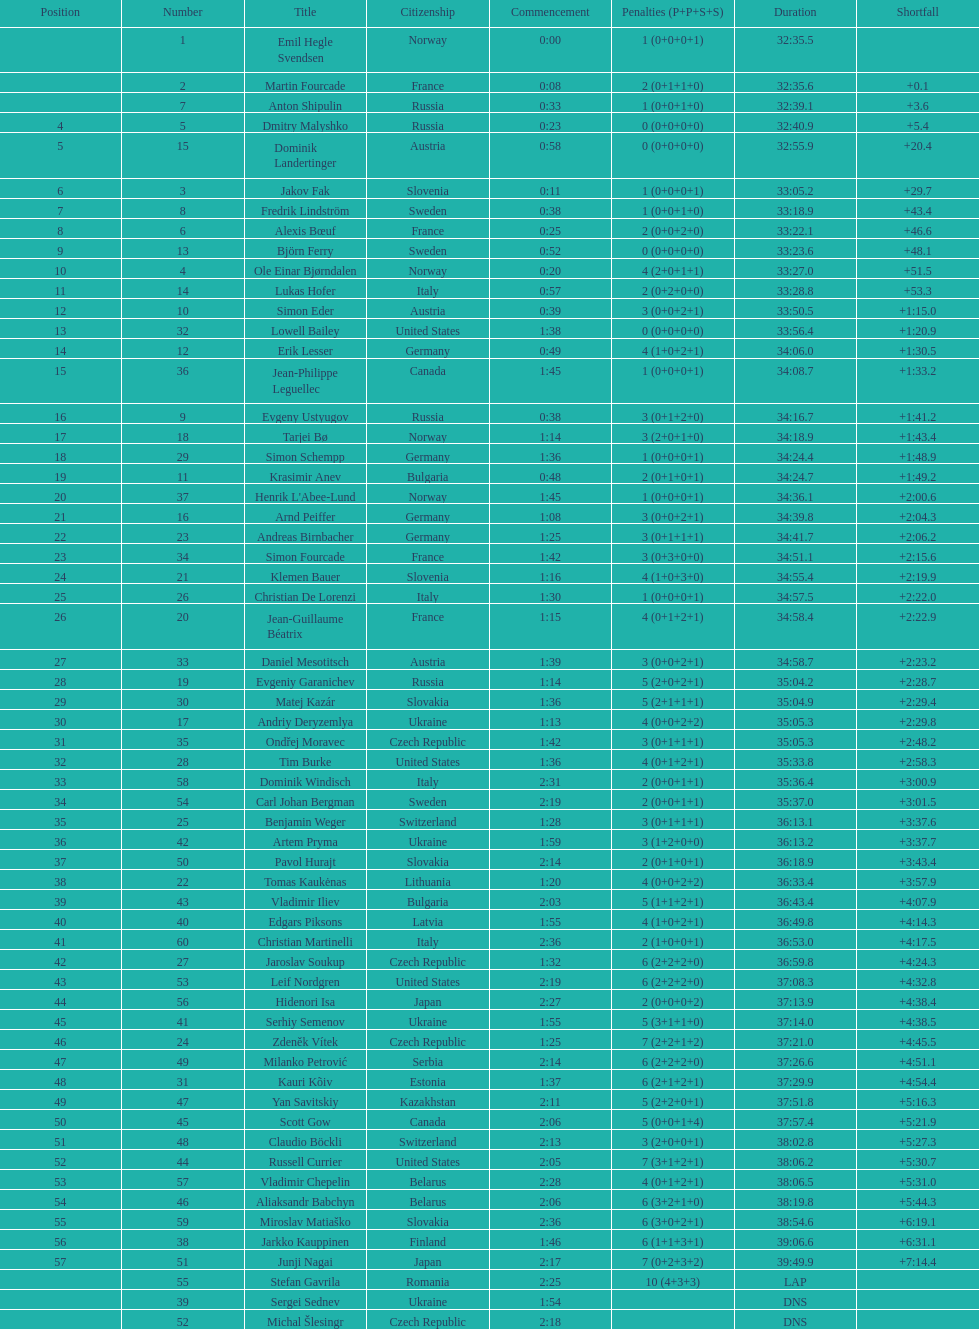How many took at least 35:00 to finish? 30. 